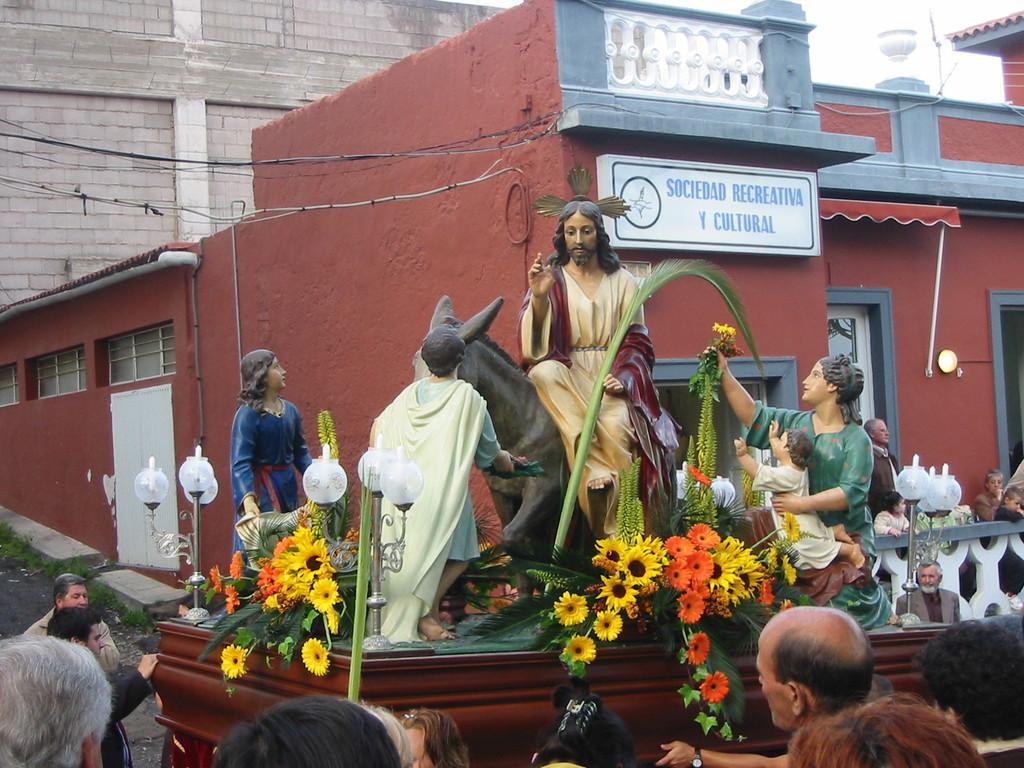Could you give a brief overview of what you see in this image? In the foreground of the picture there are people. In the center of the picture there is a vehicle, on the vehicle there are flowers and sculptures of people and horse and there are people and lights also. In the background there are buildings, board, cables, windows, wall and other objects. 